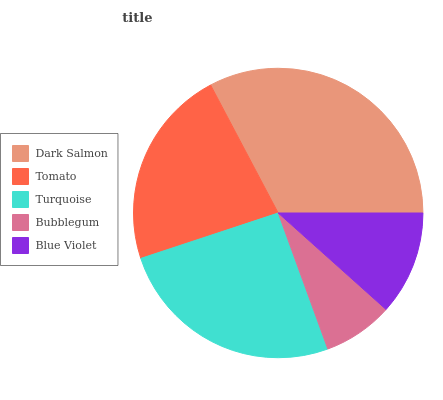Is Bubblegum the minimum?
Answer yes or no. Yes. Is Dark Salmon the maximum?
Answer yes or no. Yes. Is Tomato the minimum?
Answer yes or no. No. Is Tomato the maximum?
Answer yes or no. No. Is Dark Salmon greater than Tomato?
Answer yes or no. Yes. Is Tomato less than Dark Salmon?
Answer yes or no. Yes. Is Tomato greater than Dark Salmon?
Answer yes or no. No. Is Dark Salmon less than Tomato?
Answer yes or no. No. Is Tomato the high median?
Answer yes or no. Yes. Is Tomato the low median?
Answer yes or no. Yes. Is Blue Violet the high median?
Answer yes or no. No. Is Dark Salmon the low median?
Answer yes or no. No. 